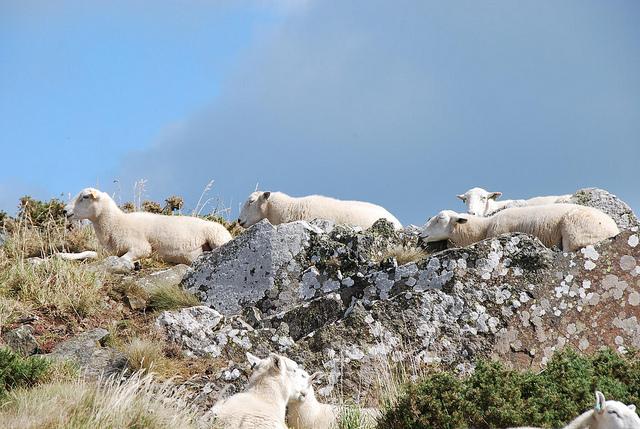How many sheep are in the picture?
Write a very short answer. 7. Are they on a mountain?
Concise answer only. Yes. What is the white scaly substance on the rocks?
Short answer required. Moss. 